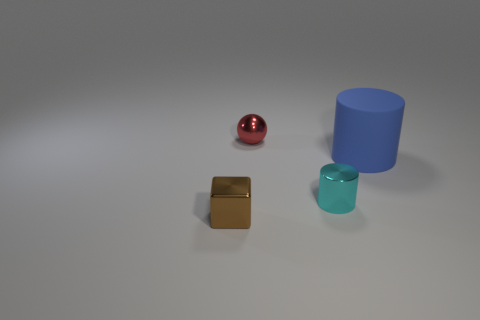Subtract all yellow cubes. Subtract all red cylinders. How many cubes are left? 1 Add 2 small things. How many objects exist? 6 Subtract all cubes. How many objects are left? 3 Subtract 1 red spheres. How many objects are left? 3 Subtract all cyan blocks. Subtract all brown cubes. How many objects are left? 3 Add 1 small shiny cylinders. How many small shiny cylinders are left? 2 Add 1 gray shiny things. How many gray shiny things exist? 1 